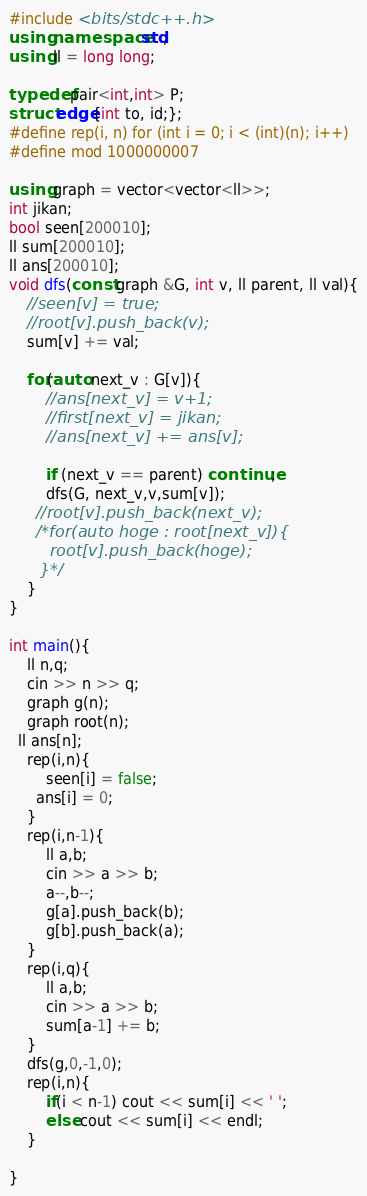<code> <loc_0><loc_0><loc_500><loc_500><_C++_>#include <bits/stdc++.h>
using namespace std;
using ll = long long;
 
typedef pair<int,int> P;
struct edge{int to, id;};
#define rep(i, n) for (int i = 0; i < (int)(n); i++)
#define mod 1000000007
 
using graph = vector<vector<ll>>;
int jikan;
bool seen[200010];
ll sum[200010];
ll ans[200010];
void dfs(const graph &G, int v, ll parent, ll val){
    //seen[v] = true;
    //root[v].push_back(v);
    sum[v] += val;
 
    for(auto next_v : G[v]){
        //ans[next_v] = v+1;
        //first[next_v] = jikan;
        //ans[next_v] += ans[v];
 
        if (next_v == parent) continue;
        dfs(G, next_v,v,sum[v]);
      //root[v].push_back(next_v);
      /*for(auto hoge : root[next_v]){
        root[v].push_back(hoge);
      }*/
    }
}
 
int main(){
    ll n,q;
    cin >> n >> q;
    graph g(n);
    graph root(n);
  ll ans[n];
    rep(i,n){
        seen[i] = false;
      ans[i] = 0;
    }
    rep(i,n-1){
        ll a,b;
        cin >> a >> b;
        a--,b--;
        g[a].push_back(b);
        g[b].push_back(a);
    }
    rep(i,q){
        ll a,b;
        cin >> a >> b;
        sum[a-1] += b;
    }
    dfs(g,0,-1,0);
    rep(i,n){
        if(i < n-1) cout << sum[i] << ' ';
        else cout << sum[i] << endl;
    }
 
}</code> 